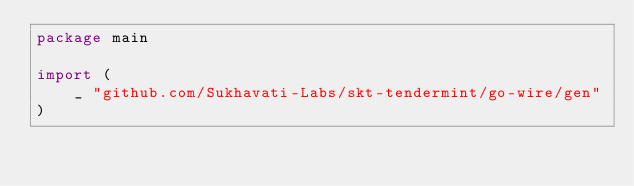<code> <loc_0><loc_0><loc_500><loc_500><_Go_>package main

import (
	_ "github.com/Sukhavati-Labs/skt-tendermint/go-wire/gen"
)
</code> 